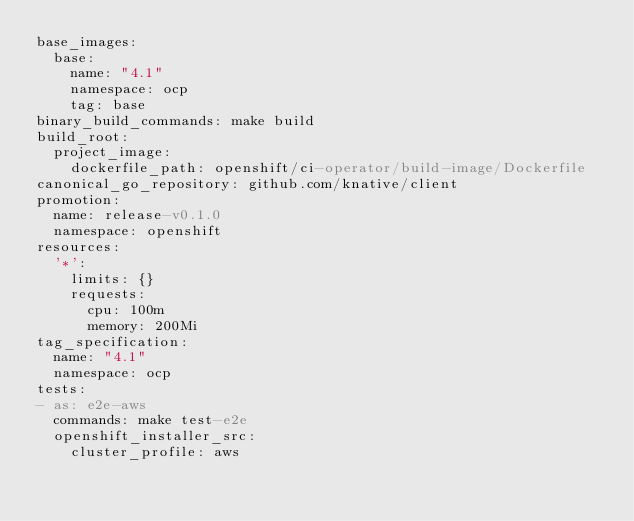<code> <loc_0><loc_0><loc_500><loc_500><_YAML_>base_images:
  base:
    name: "4.1"
    namespace: ocp
    tag: base
binary_build_commands: make build
build_root:
  project_image:
    dockerfile_path: openshift/ci-operator/build-image/Dockerfile
canonical_go_repository: github.com/knative/client
promotion:
  name: release-v0.1.0
  namespace: openshift
resources:
  '*':
    limits: {}
    requests:
      cpu: 100m
      memory: 200Mi
tag_specification:
  name: "4.1"
  namespace: ocp
tests:
- as: e2e-aws
  commands: make test-e2e
  openshift_installer_src:
    cluster_profile: aws
</code> 